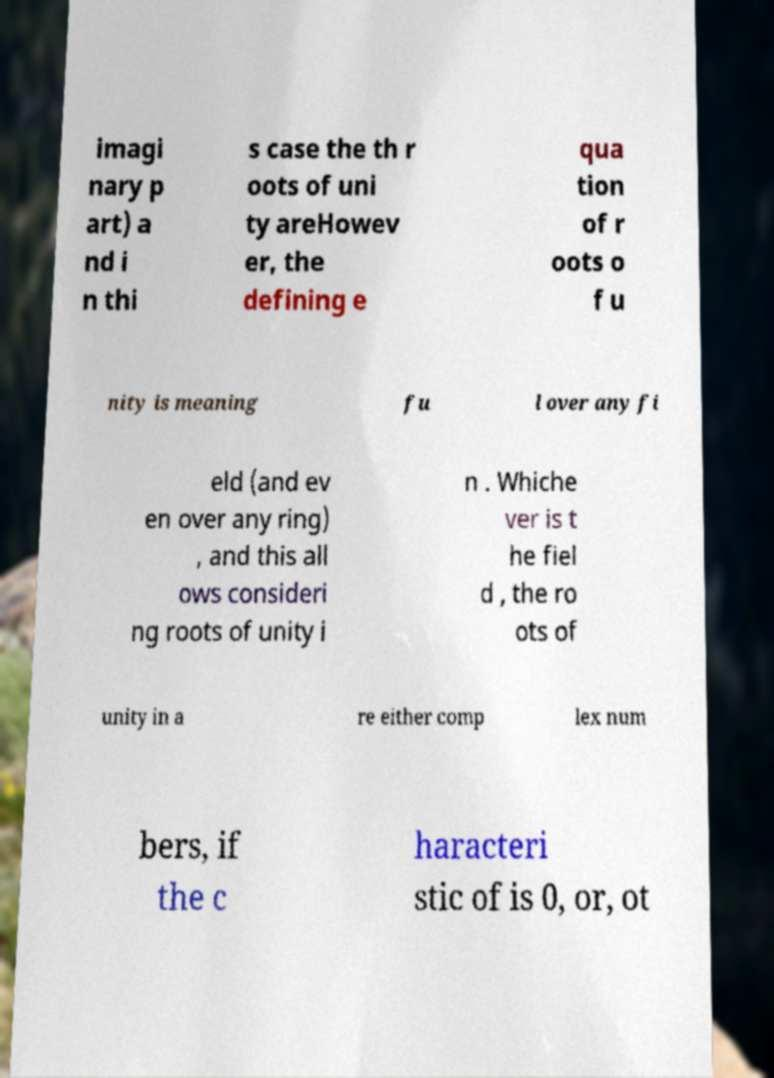What messages or text are displayed in this image? I need them in a readable, typed format. imagi nary p art) a nd i n thi s case the th r oots of uni ty areHowev er, the defining e qua tion of r oots o f u nity is meaning fu l over any fi eld (and ev en over any ring) , and this all ows consideri ng roots of unity i n . Whiche ver is t he fiel d , the ro ots of unity in a re either comp lex num bers, if the c haracteri stic of is 0, or, ot 